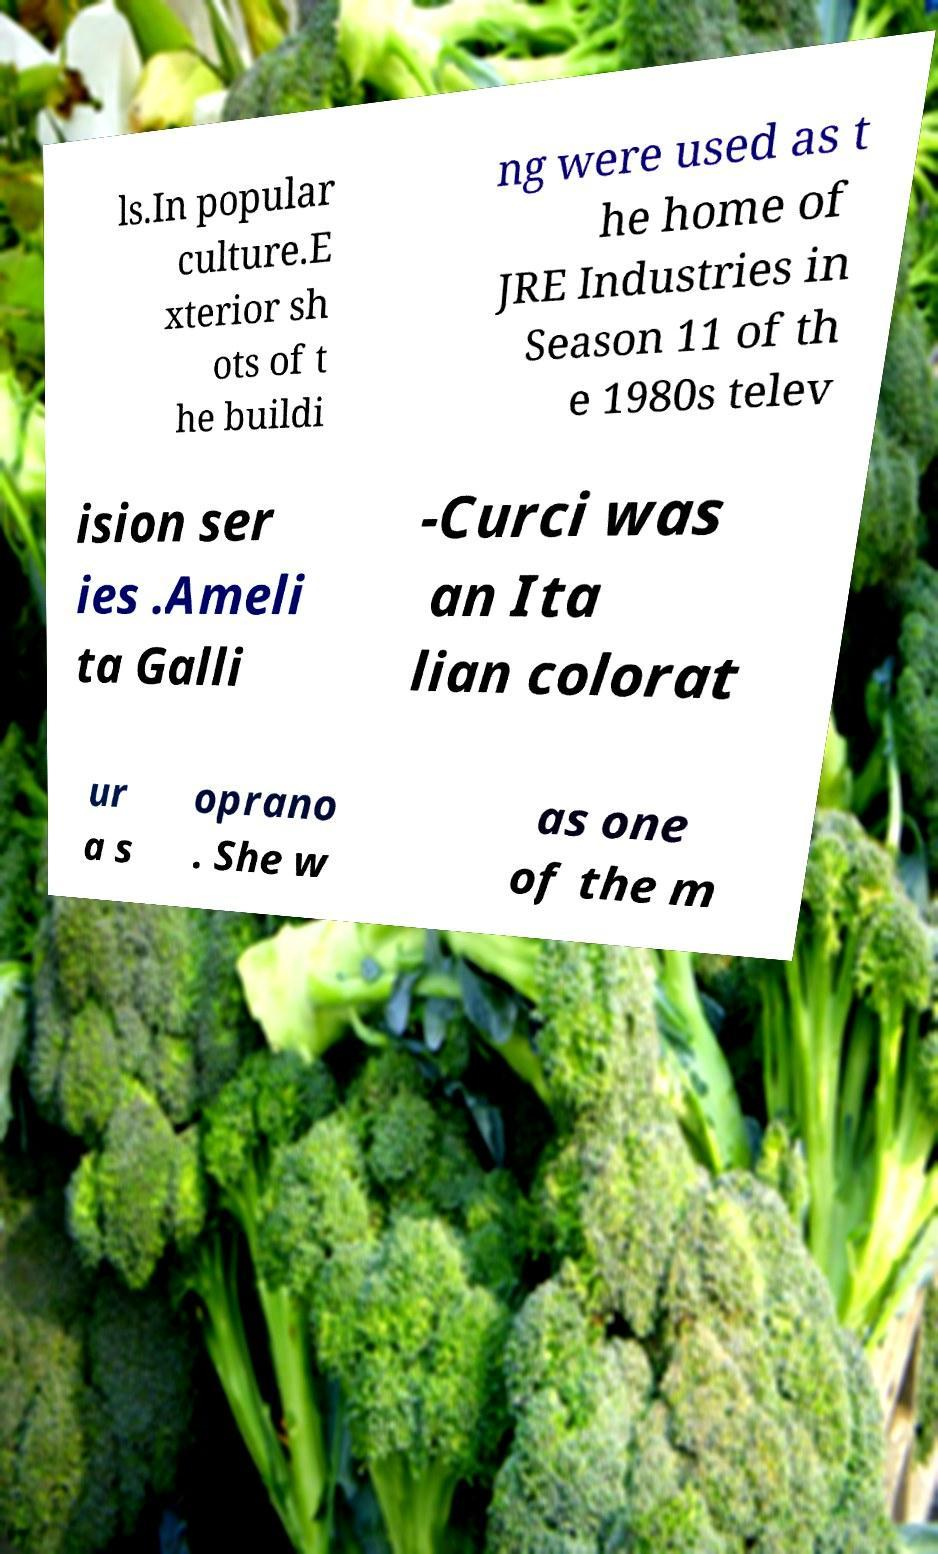Could you assist in decoding the text presented in this image and type it out clearly? ls.In popular culture.E xterior sh ots of t he buildi ng were used as t he home of JRE Industries in Season 11 of th e 1980s telev ision ser ies .Ameli ta Galli -Curci was an Ita lian colorat ur a s oprano . She w as one of the m 